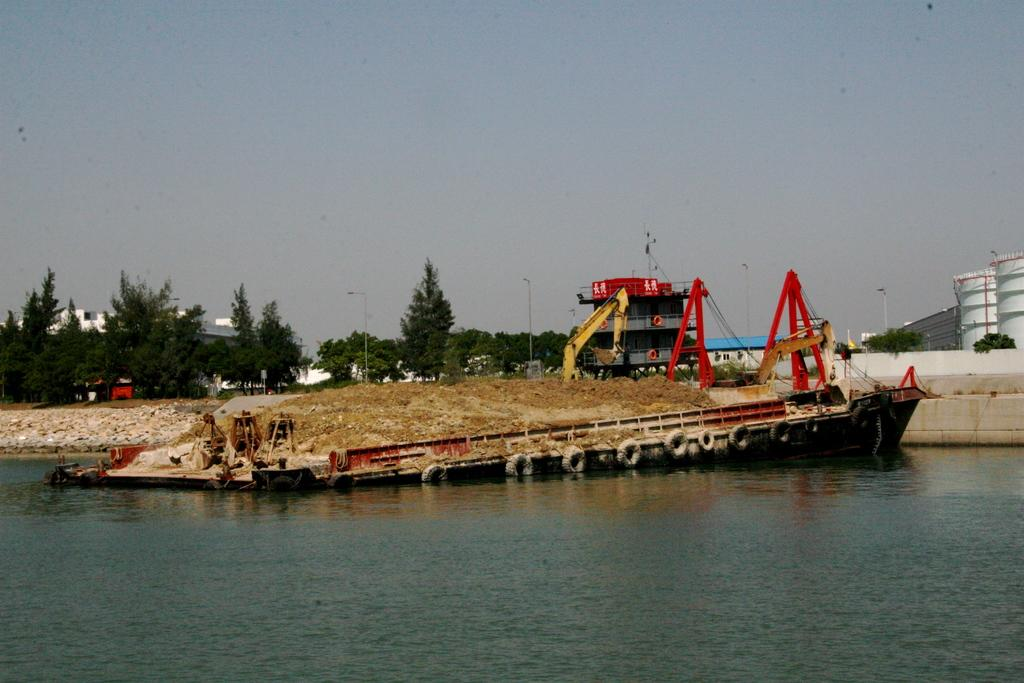What is located in the water in the image? There is a boat in the water in the image. What type of structures can be seen in the image? There are cranes, trees, buildings, and streetlights in the image. What is visible in the sky in the image? The sky is visible in the image. What type of turkey is being served on a plate in the image? There is no turkey or plate present in the image. What type of metal is used to construct the cranes in the image? The image does not provide information about the type of metal used to construct the cranes. 